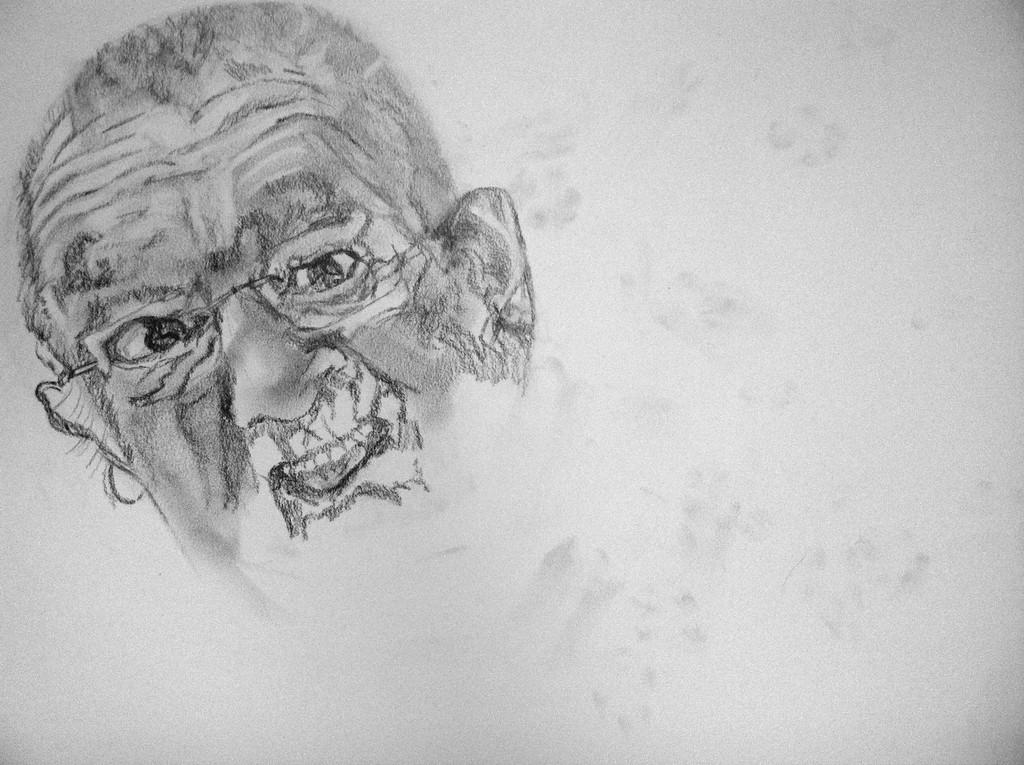What type of image is depicted in the picture? The image is a drawing. What is the main subject of the drawing? There is a drawing of a person's face in the image. In which direction is the drawing of the person's face facing? The drawing of the person's face is towards the left side. What type of cork can be seen in the image? There is no cork present in the image. What government policy is being discussed in the image? There is no discussion of government policies in the image; it is a drawing of a person's face. 